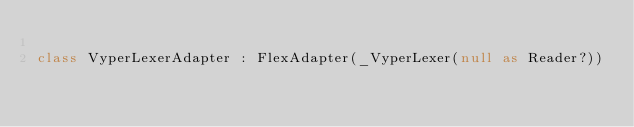Convert code to text. <code><loc_0><loc_0><loc_500><loc_500><_Kotlin_>
class VyperLexerAdapter : FlexAdapter(_VyperLexer(null as Reader?))
</code> 